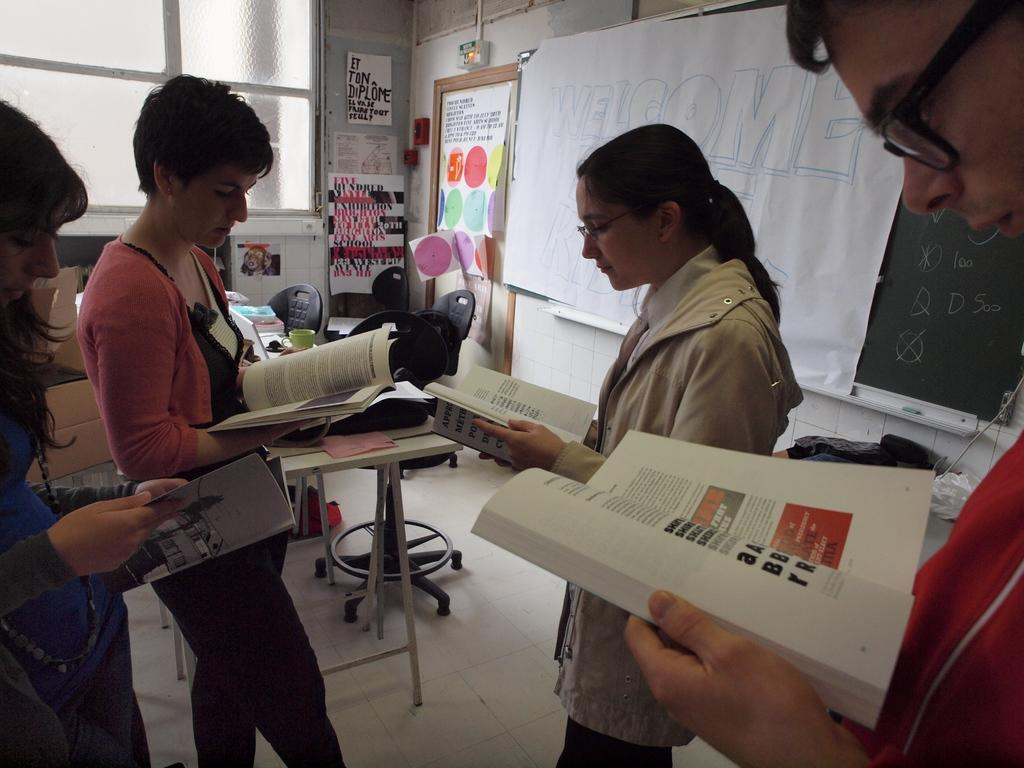How many people are in the image? There are four people in the image. What are the people doing in the image? The people are standing in the image. What objects are the people holding in their hands? The people are holding books in their hands. What can be seen on the wall in the image? There is a board visible in the image. What type of furniture is present in the image? There are chairs and tables in the image. What type of scarf is the person wearing in the image? There is no scarf visible in the image; the people are holding books in their hands. 